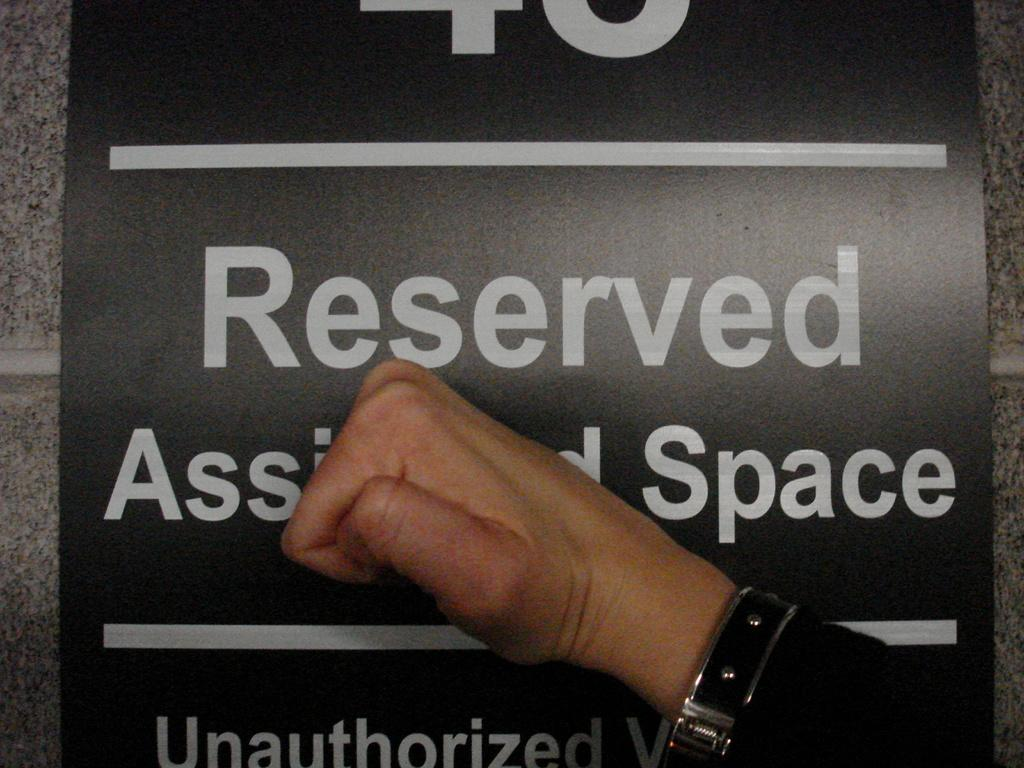<image>
Summarize the visual content of the image. A hand knocking on a sign that says Reserved. 